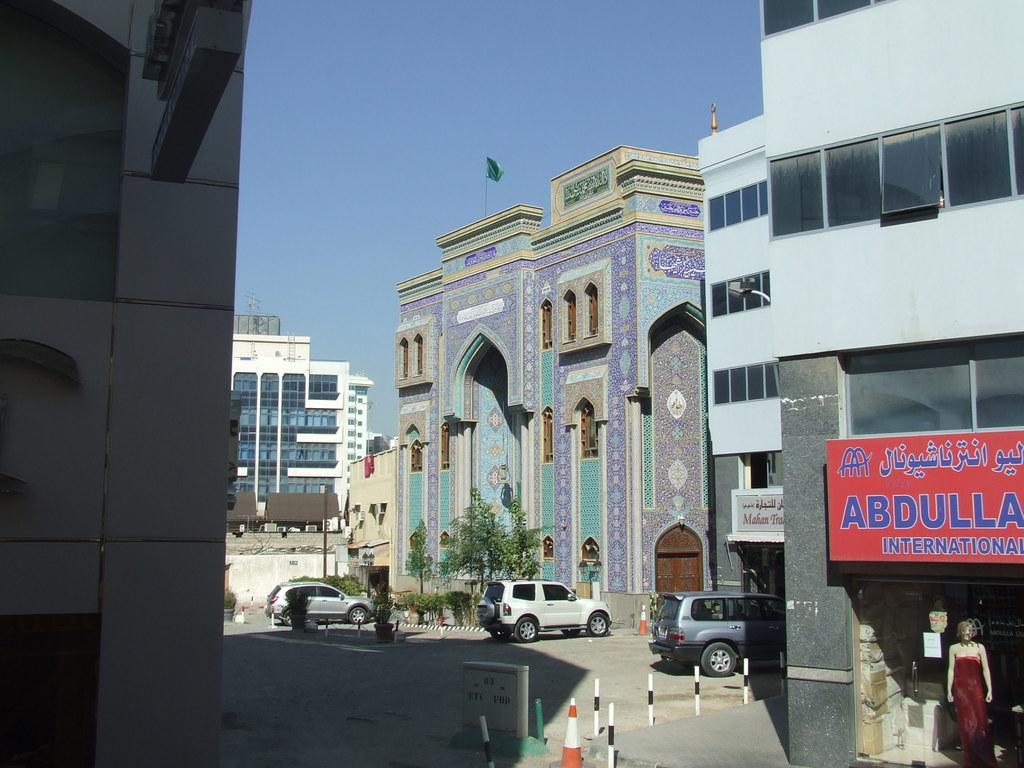Please provide a concise description of this image. In this image we can see few buildings, vehicles on the road, few rods, trees, a flag on the building, a mannequin, boards with text and the sky in the background. 